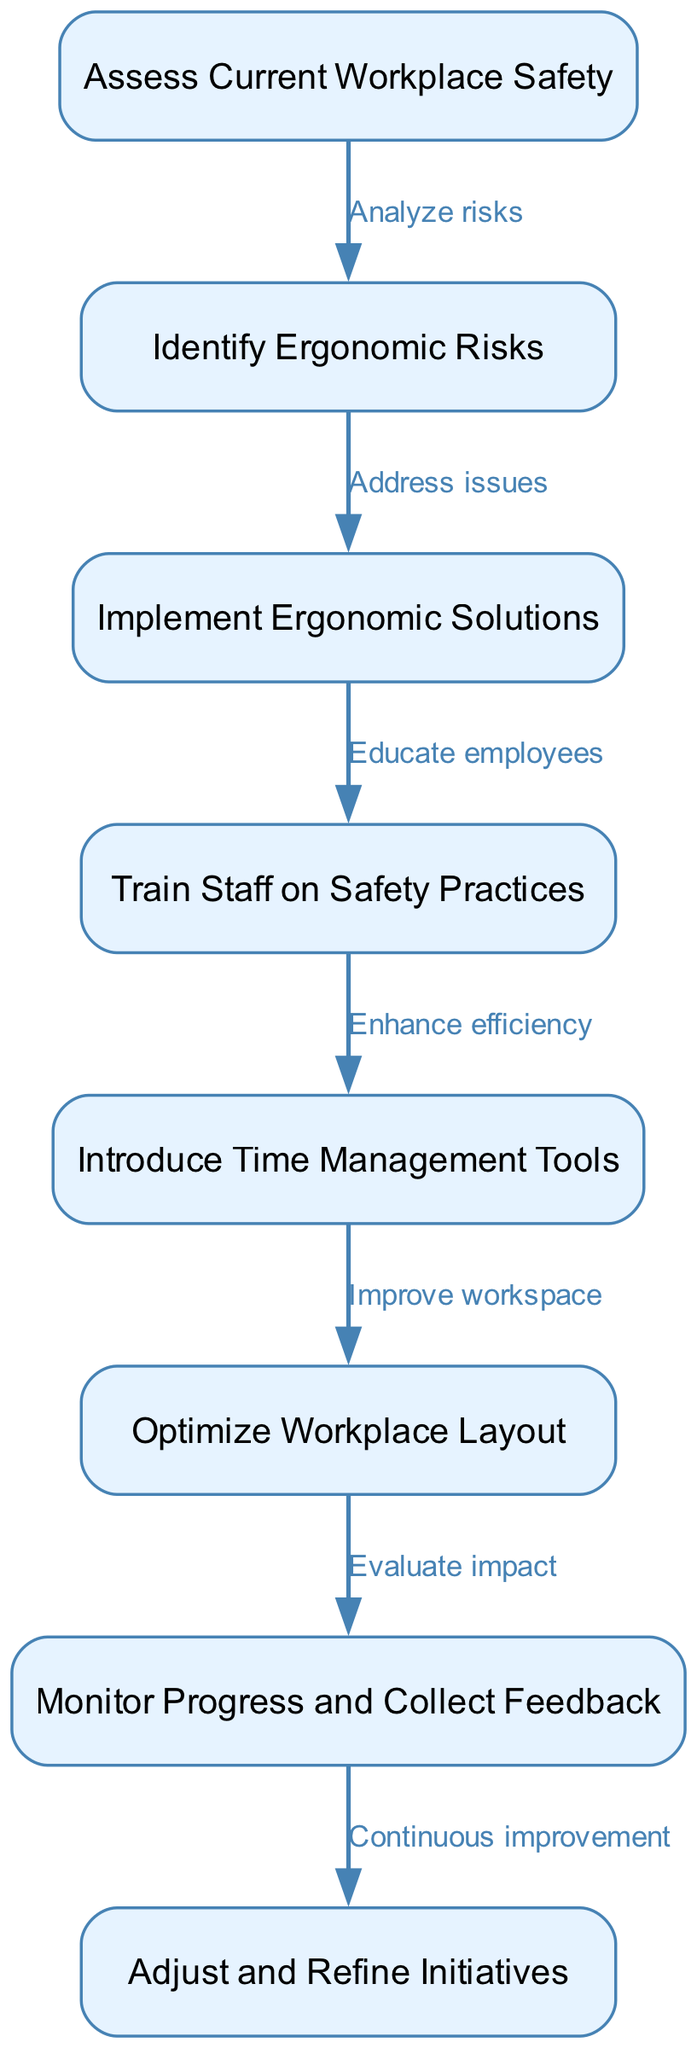What is the first step in the process? The diagram shows that the first step, represented by the first node, is "Assess Current Workplace Safety." This is derived from the initial node's position in the flow.
Answer: Assess Current Workplace Safety How many nodes are there in total? Counting the number of distinct nodes listed in the diagram, there are a total of 8 nodes. This is determined by simply enumerating the node entries provided.
Answer: 8 What does the edge between nodes 2 and 3 represent? The edge connects the nodes "Identify Ergonomic Risks" (node 2) and "Implement Ergonomic Solutions" (node 3) and is labeled "Address issues." This indicates the action taken from identifying risks to addressing them with solutions.
Answer: Address issues What is the last step in the implementation process? The diagram outlines that the final step, which is the last node in the sequence, is "Adjust and Refine Initiatives," suggesting that after monitoring progress, there will be continuous improvement efforts.
Answer: Adjust and Refine Initiatives Which step follows the training of staff on safety practices? According to the diagram, the step that follows "Train Staff on Safety Practices" (node 4) is "Introduce Time Management Tools" (node 5). This is visualized by the edge pointing from node 4 to node 5.
Answer: Introduce Time Management Tools What is the relationship between monitoring progress and refining initiatives? The edge from "Monitor Progress and Collect Feedback" (node 7) to "Adjust and Refine Initiatives" (node 8), labeled "Continuous improvement," illustrates that monitoring feedback is essential for adjusting and refining ongoing initiatives. This highlights an iterative process.
Answer: Continuous improvement What is involved in optimizing workplace layout? The diagram indicates that "Optimize Workplace Layout" (node 6) is preceded by "Introduce Time Management Tools" (node 5), suggesting that workplace optimization is part of improving efficiency and productivity management, informed by the previous steps.
Answer: Improve workspace Which node represents the action of educating employees? The node that explicitly mentions educating employees is "Train Staff on Safety Practices," which is the fourth node in the sequence. This indicates a dedicated step for staff development in safety practices.
Answer: Train Staff on Safety Practices 